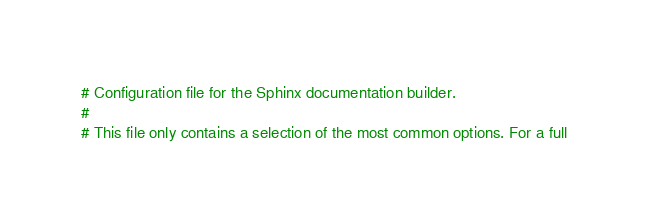<code> <loc_0><loc_0><loc_500><loc_500><_Python_># Configuration file for the Sphinx documentation builder.
#
# This file only contains a selection of the most common options. For a full</code> 